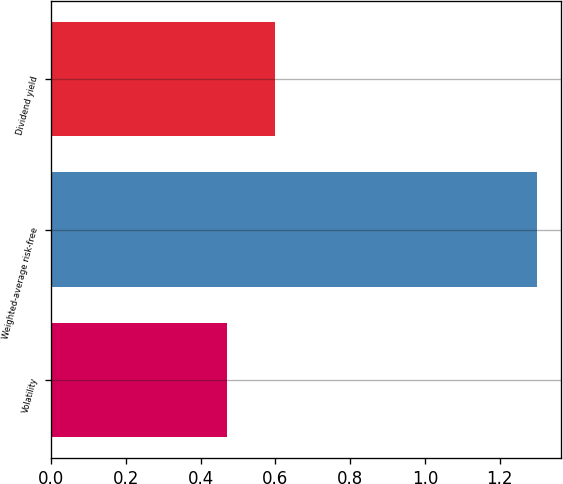<chart> <loc_0><loc_0><loc_500><loc_500><bar_chart><fcel>Volatility<fcel>Weighted-average risk-free<fcel>Dividend yield<nl><fcel>0.47<fcel>1.3<fcel>0.6<nl></chart> 